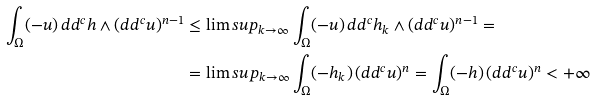Convert formula to latex. <formula><loc_0><loc_0><loc_500><loc_500>\int _ { \Omega } ( - u ) \, d d ^ { c } h \wedge ( d d ^ { c } u ) ^ { n - 1 } & \leq \lim s u p _ { k \to \infty } \int _ { \Omega } ( - u ) \, d d ^ { c } h _ { k } \wedge ( d d ^ { c } u ) ^ { n - 1 } = \\ & = \lim s u p _ { k \to \infty } \int _ { \Omega } ( - h _ { k } ) \, ( d d ^ { c } u ) ^ { n } = \int _ { \Omega } ( - h ) \, ( d d ^ { c } u ) ^ { n } < + \infty</formula> 